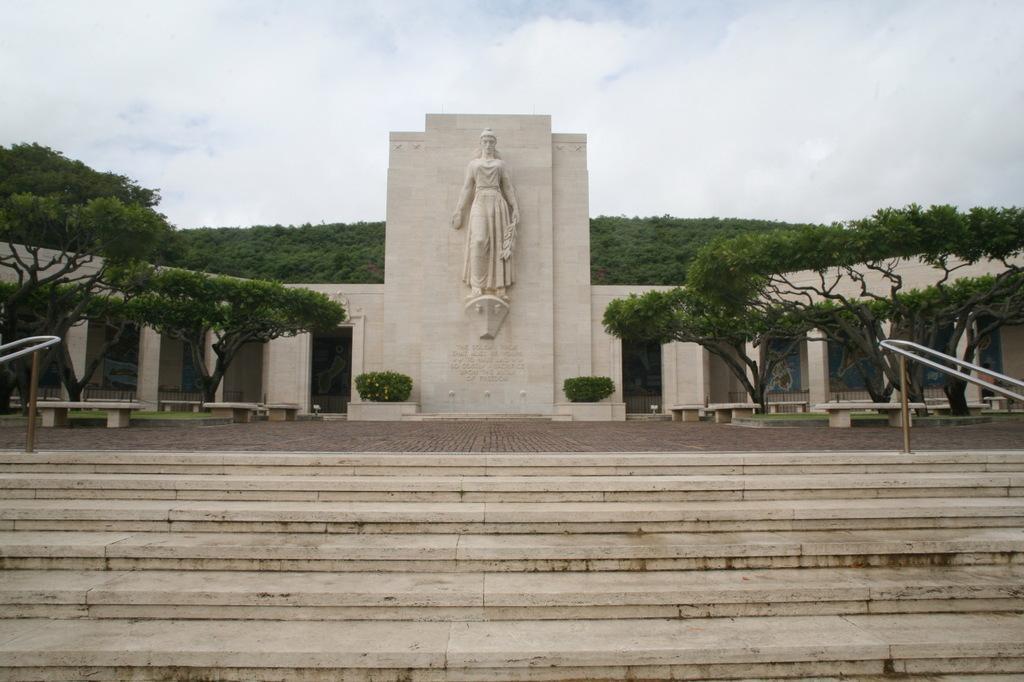How would you summarize this image in a sentence or two? In this image we can see a sculpture carved on the walls of the building. We can also see the plants, benches, trees and also the hill. We can see the path, stairs and also the sky with the clouds in the background. 